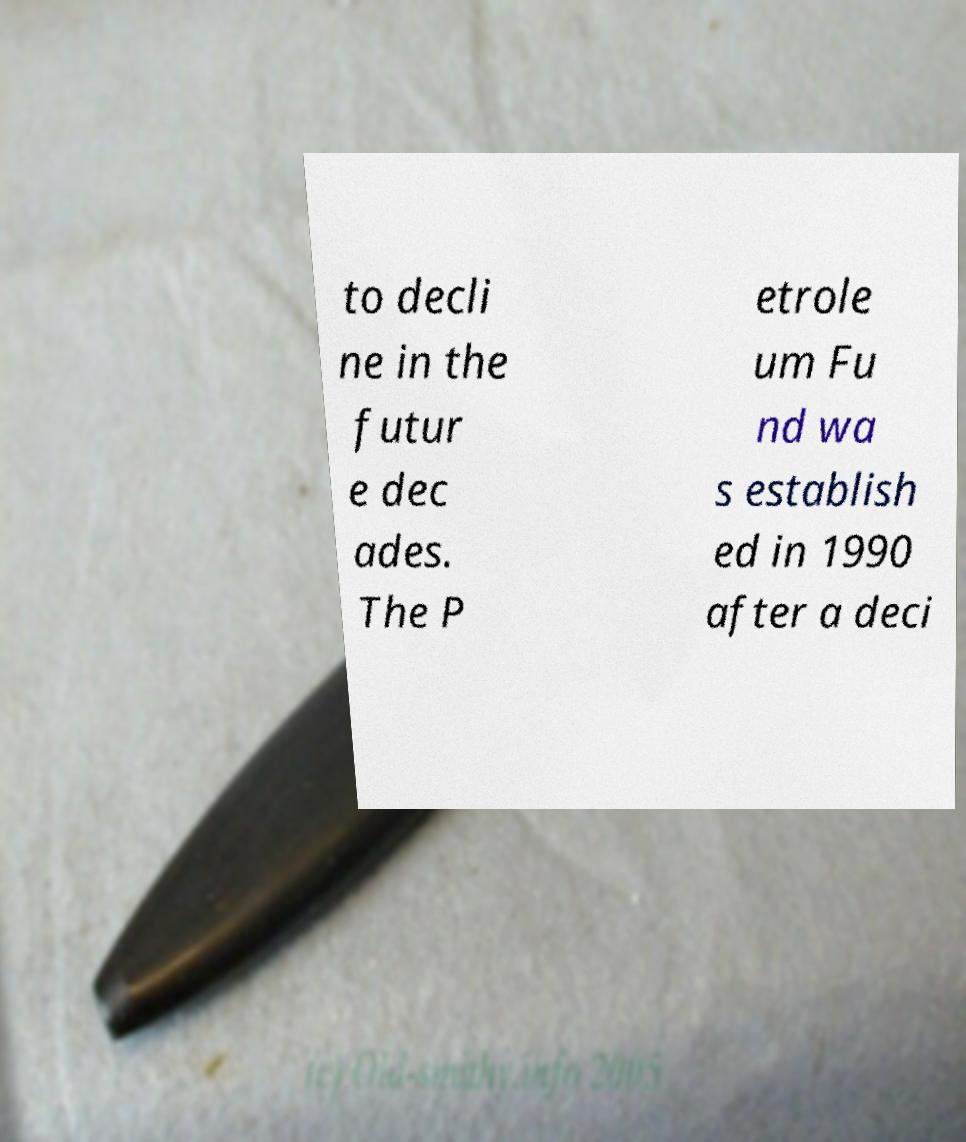Could you assist in decoding the text presented in this image and type it out clearly? to decli ne in the futur e dec ades. The P etrole um Fu nd wa s establish ed in 1990 after a deci 